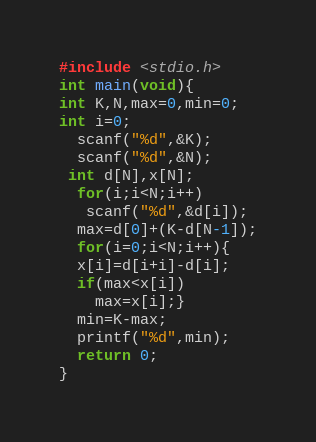Convert code to text. <code><loc_0><loc_0><loc_500><loc_500><_C_>#include <stdio.h>
int main(void){
int K,N,max=0,min=0;
int i=0;
  scanf("%d",&K);
  scanf("%d",&N);
 int d[N],x[N];
  for(i;i<N;i++)
   scanf("%d",&d[i]);
  max=d[0]+(K-d[N-1]);
  for(i=0;i<N;i++){
  x[i]=d[i+i]-d[i];
  if(max<x[i])
    max=x[i];}
  min=K-max;
  printf("%d",min);
  return 0;
}
</code> 